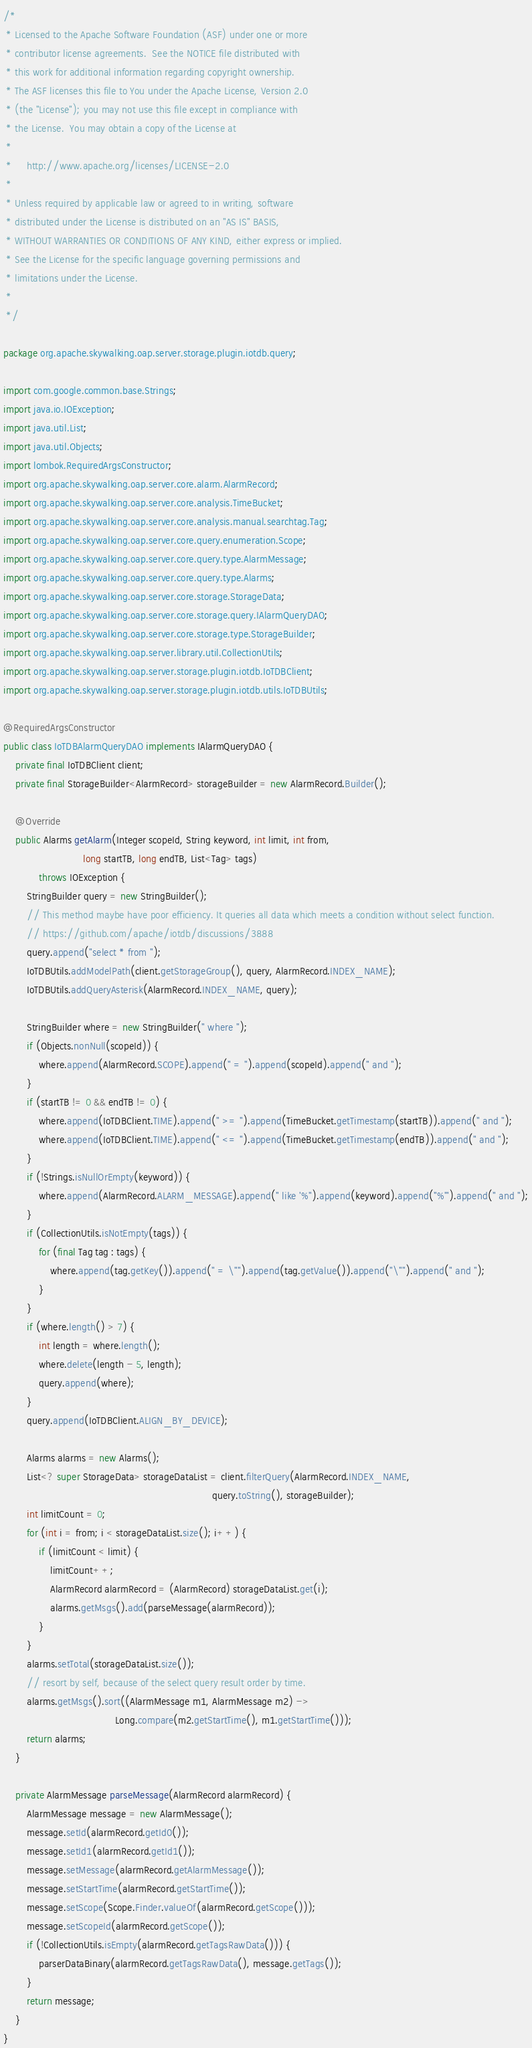<code> <loc_0><loc_0><loc_500><loc_500><_Java_>/*
 * Licensed to the Apache Software Foundation (ASF) under one or more
 * contributor license agreements.  See the NOTICE file distributed with
 * this work for additional information regarding copyright ownership.
 * The ASF licenses this file to You under the Apache License, Version 2.0
 * (the "License"); you may not use this file except in compliance with
 * the License.  You may obtain a copy of the License at
 *
 *     http://www.apache.org/licenses/LICENSE-2.0
 *
 * Unless required by applicable law or agreed to in writing, software
 * distributed under the License is distributed on an "AS IS" BASIS,
 * WITHOUT WARRANTIES OR CONDITIONS OF ANY KIND, either express or implied.
 * See the License for the specific language governing permissions and
 * limitations under the License.
 *
 */

package org.apache.skywalking.oap.server.storage.plugin.iotdb.query;

import com.google.common.base.Strings;
import java.io.IOException;
import java.util.List;
import java.util.Objects;
import lombok.RequiredArgsConstructor;
import org.apache.skywalking.oap.server.core.alarm.AlarmRecord;
import org.apache.skywalking.oap.server.core.analysis.TimeBucket;
import org.apache.skywalking.oap.server.core.analysis.manual.searchtag.Tag;
import org.apache.skywalking.oap.server.core.query.enumeration.Scope;
import org.apache.skywalking.oap.server.core.query.type.AlarmMessage;
import org.apache.skywalking.oap.server.core.query.type.Alarms;
import org.apache.skywalking.oap.server.core.storage.StorageData;
import org.apache.skywalking.oap.server.core.storage.query.IAlarmQueryDAO;
import org.apache.skywalking.oap.server.core.storage.type.StorageBuilder;
import org.apache.skywalking.oap.server.library.util.CollectionUtils;
import org.apache.skywalking.oap.server.storage.plugin.iotdb.IoTDBClient;
import org.apache.skywalking.oap.server.storage.plugin.iotdb.utils.IoTDBUtils;

@RequiredArgsConstructor
public class IoTDBAlarmQueryDAO implements IAlarmQueryDAO {
    private final IoTDBClient client;
    private final StorageBuilder<AlarmRecord> storageBuilder = new AlarmRecord.Builder();

    @Override
    public Alarms getAlarm(Integer scopeId, String keyword, int limit, int from,
                           long startTB, long endTB, List<Tag> tags)
            throws IOException {
        StringBuilder query = new StringBuilder();
        // This method maybe have poor efficiency. It queries all data which meets a condition without select function.
        // https://github.com/apache/iotdb/discussions/3888
        query.append("select * from ");
        IoTDBUtils.addModelPath(client.getStorageGroup(), query, AlarmRecord.INDEX_NAME);
        IoTDBUtils.addQueryAsterisk(AlarmRecord.INDEX_NAME, query);

        StringBuilder where = new StringBuilder(" where ");
        if (Objects.nonNull(scopeId)) {
            where.append(AlarmRecord.SCOPE).append(" = ").append(scopeId).append(" and ");
        }
        if (startTB != 0 && endTB != 0) {
            where.append(IoTDBClient.TIME).append(" >= ").append(TimeBucket.getTimestamp(startTB)).append(" and ");
            where.append(IoTDBClient.TIME).append(" <= ").append(TimeBucket.getTimestamp(endTB)).append(" and ");
        }
        if (!Strings.isNullOrEmpty(keyword)) {
            where.append(AlarmRecord.ALARM_MESSAGE).append(" like '%").append(keyword).append("%'").append(" and ");
        }
        if (CollectionUtils.isNotEmpty(tags)) {
            for (final Tag tag : tags) {
                where.append(tag.getKey()).append(" = \"").append(tag.getValue()).append("\"").append(" and ");
            }
        }
        if (where.length() > 7) {
            int length = where.length();
            where.delete(length - 5, length);
            query.append(where);
        }
        query.append(IoTDBClient.ALIGN_BY_DEVICE);

        Alarms alarms = new Alarms();
        List<? super StorageData> storageDataList = client.filterQuery(AlarmRecord.INDEX_NAME,
                                                                       query.toString(), storageBuilder);
        int limitCount = 0;
        for (int i = from; i < storageDataList.size(); i++) {
            if (limitCount < limit) {
                limitCount++;
                AlarmRecord alarmRecord = (AlarmRecord) storageDataList.get(i);
                alarms.getMsgs().add(parseMessage(alarmRecord));
            }
        }
        alarms.setTotal(storageDataList.size());
        // resort by self, because of the select query result order by time.
        alarms.getMsgs().sort((AlarmMessage m1, AlarmMessage m2) ->
                                      Long.compare(m2.getStartTime(), m1.getStartTime()));
        return alarms;
    }

    private AlarmMessage parseMessage(AlarmRecord alarmRecord) {
        AlarmMessage message = new AlarmMessage();
        message.setId(alarmRecord.getId0());
        message.setId1(alarmRecord.getId1());
        message.setMessage(alarmRecord.getAlarmMessage());
        message.setStartTime(alarmRecord.getStartTime());
        message.setScope(Scope.Finder.valueOf(alarmRecord.getScope()));
        message.setScopeId(alarmRecord.getScope());
        if (!CollectionUtils.isEmpty(alarmRecord.getTagsRawData())) {
            parserDataBinary(alarmRecord.getTagsRawData(), message.getTags());
        }
        return message;
    }
}
</code> 